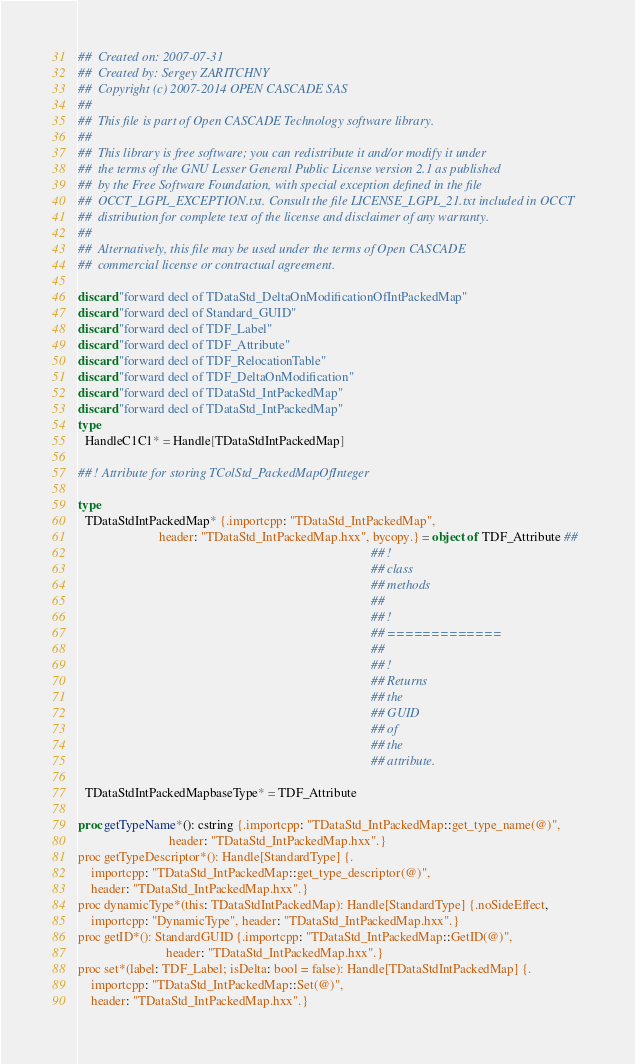Convert code to text. <code><loc_0><loc_0><loc_500><loc_500><_Nim_>##  Created on: 2007-07-31
##  Created by: Sergey ZARITCHNY
##  Copyright (c) 2007-2014 OPEN CASCADE SAS
##
##  This file is part of Open CASCADE Technology software library.
##
##  This library is free software; you can redistribute it and/or modify it under
##  the terms of the GNU Lesser General Public License version 2.1 as published
##  by the Free Software Foundation, with special exception defined in the file
##  OCCT_LGPL_EXCEPTION.txt. Consult the file LICENSE_LGPL_21.txt included in OCCT
##  distribution for complete text of the license and disclaimer of any warranty.
##
##  Alternatively, this file may be used under the terms of Open CASCADE
##  commercial license or contractual agreement.

discard "forward decl of TDataStd_DeltaOnModificationOfIntPackedMap"
discard "forward decl of Standard_GUID"
discard "forward decl of TDF_Label"
discard "forward decl of TDF_Attribute"
discard "forward decl of TDF_RelocationTable"
discard "forward decl of TDF_DeltaOnModification"
discard "forward decl of TDataStd_IntPackedMap"
discard "forward decl of TDataStd_IntPackedMap"
type
  HandleC1C1* = Handle[TDataStdIntPackedMap]

## ! Attribute for storing TColStd_PackedMapOfInteger

type
  TDataStdIntPackedMap* {.importcpp: "TDataStd_IntPackedMap",
                         header: "TDataStd_IntPackedMap.hxx", bycopy.} = object of TDF_Attribute ##
                                                                                          ## !
                                                                                          ## class
                                                                                          ## methods
                                                                                          ##
                                                                                          ## !
                                                                                          ## =============
                                                                                          ##
                                                                                          ## !
                                                                                          ## Returns
                                                                                          ## the
                                                                                          ## GUID
                                                                                          ## of
                                                                                          ## the
                                                                                          ## attribute.

  TDataStdIntPackedMapbaseType* = TDF_Attribute

proc getTypeName*(): cstring {.importcpp: "TDataStd_IntPackedMap::get_type_name(@)",
                            header: "TDataStd_IntPackedMap.hxx".}
proc getTypeDescriptor*(): Handle[StandardType] {.
    importcpp: "TDataStd_IntPackedMap::get_type_descriptor(@)",
    header: "TDataStd_IntPackedMap.hxx".}
proc dynamicType*(this: TDataStdIntPackedMap): Handle[StandardType] {.noSideEffect,
    importcpp: "DynamicType", header: "TDataStd_IntPackedMap.hxx".}
proc getID*(): StandardGUID {.importcpp: "TDataStd_IntPackedMap::GetID(@)",
                           header: "TDataStd_IntPackedMap.hxx".}
proc set*(label: TDF_Label; isDelta: bool = false): Handle[TDataStdIntPackedMap] {.
    importcpp: "TDataStd_IntPackedMap::Set(@)",
    header: "TDataStd_IntPackedMap.hxx".}</code> 